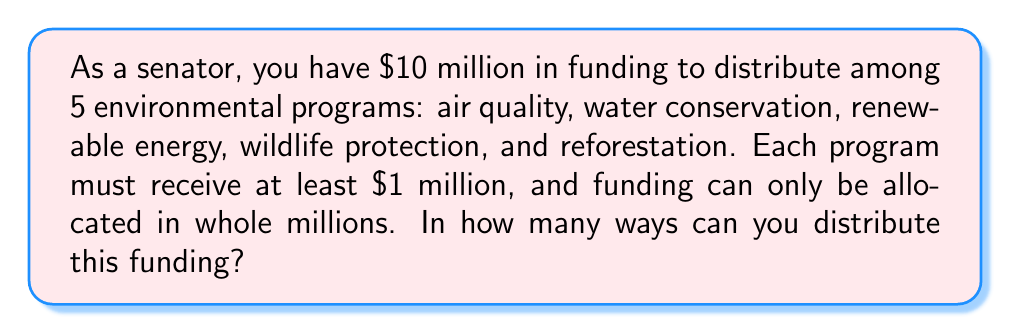Can you solve this math problem? Let's approach this step-by-step:

1) First, we need to give each program the minimum $1 million. This leaves us with $5 million to distribute.

2) Now, we need to find the number of ways to distribute 5 indistinguishable objects (millions of dollars) among 5 distinguishable containers (programs).

3) This is a classic stars and bars problem. The formula for this is:

   $${n+k-1 \choose k-1}$$

   Where $n$ is the number of indistinguishable objects and $k$ is the number of distinguishable containers.

4) In our case, $n = 5$ (remaining millions) and $k = 5$ (programs).

5) Plugging these values into the formula:

   $${5+5-1 \choose 5-1} = {9 \choose 4}$$

6) We can calculate this:

   $${9 \choose 4} = \frac{9!}{4!(9-4)!} = \frac{9!}{4!5!} = \frac{9 \cdot 8 \cdot 7 \cdot 6}{4 \cdot 3 \cdot 2 \cdot 1} = 126$$

Therefore, there are 126 ways to distribute the funding.
Answer: 126 